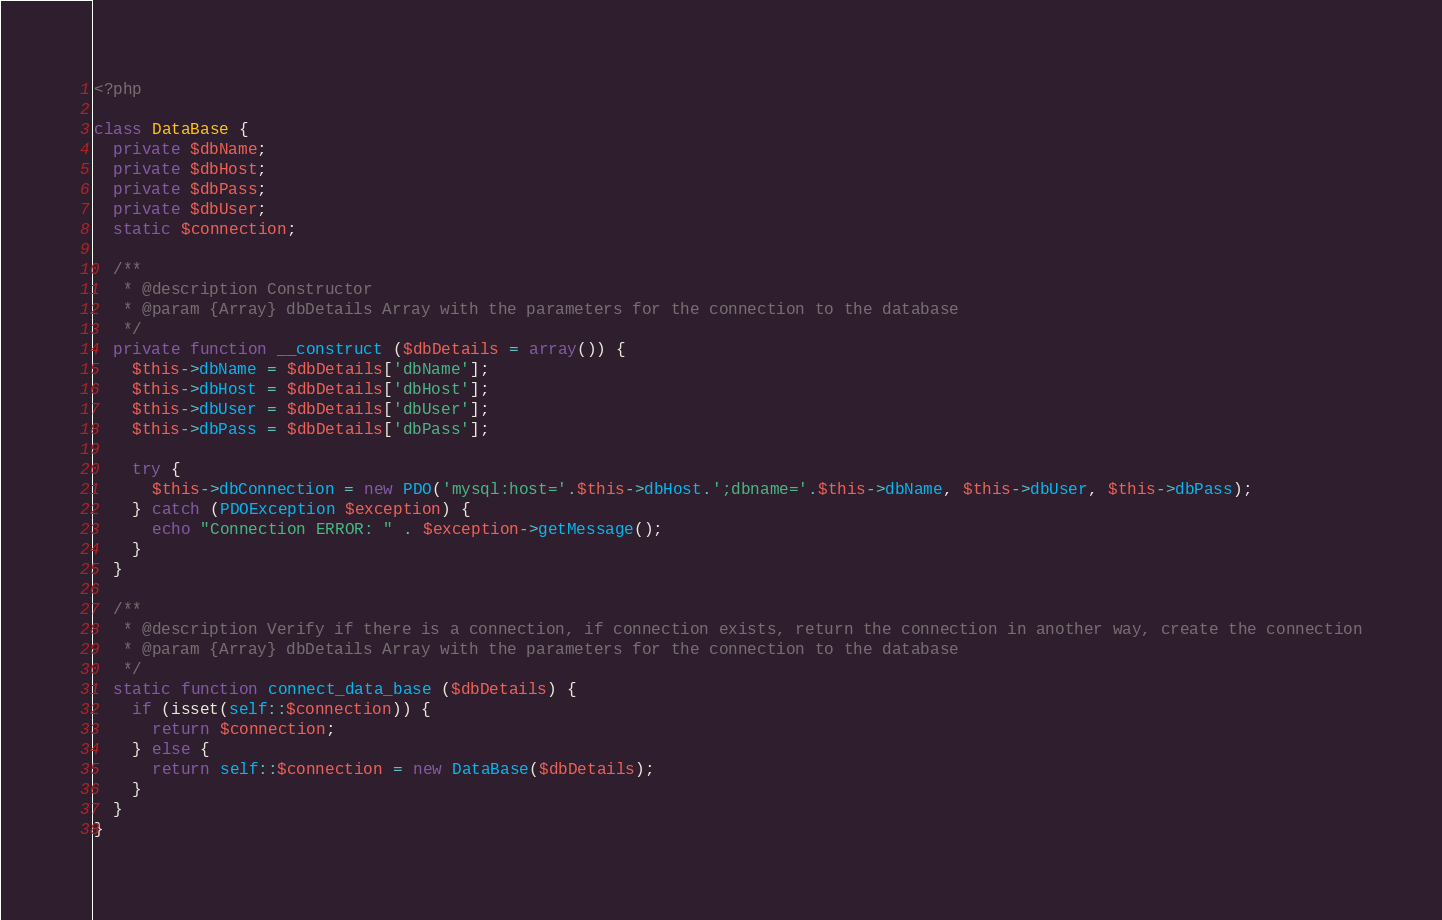Convert code to text. <code><loc_0><loc_0><loc_500><loc_500><_PHP_><?php

class DataBase {
  private $dbName;
  private $dbHost;
  private $dbPass;
  private $dbUser;
  static $connection;

  /**
   * @description Constructor
   * @param {Array} dbDetails Array with the parameters for the connection to the database 
   */
  private function __construct ($dbDetails = array()) {
    $this->dbName = $dbDetails['dbName'];
    $this->dbHost = $dbDetails['dbHost'];
    $this->dbUser = $dbDetails['dbUser'];
    $this->dbPass = $dbDetails['dbPass'];

    try {
      $this->dbConnection = new PDO('mysql:host='.$this->dbHost.';dbname='.$this->dbName, $this->dbUser, $this->dbPass);
    } catch (PDOException $exception) {
      echo "Connection ERROR: " . $exception->getMessage();
    }      
  }

  /**
   * @description Verify if there is a connection, if connection exists, return the connection in another way, create the connection
   * @param {Array} dbDetails Array with the parameters for the connection to the database
   */
  static function connect_data_base ($dbDetails) {
    if (isset(self::$connection)) {
      return $connection;
    } else {
      return self::$connection = new DataBase($dbDetails);
    }
  }
}
</code> 